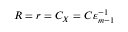Convert formula to latex. <formula><loc_0><loc_0><loc_500><loc_500>R = r = C _ { X } = C \varepsilon _ { m - 1 } ^ { - 1 }</formula> 